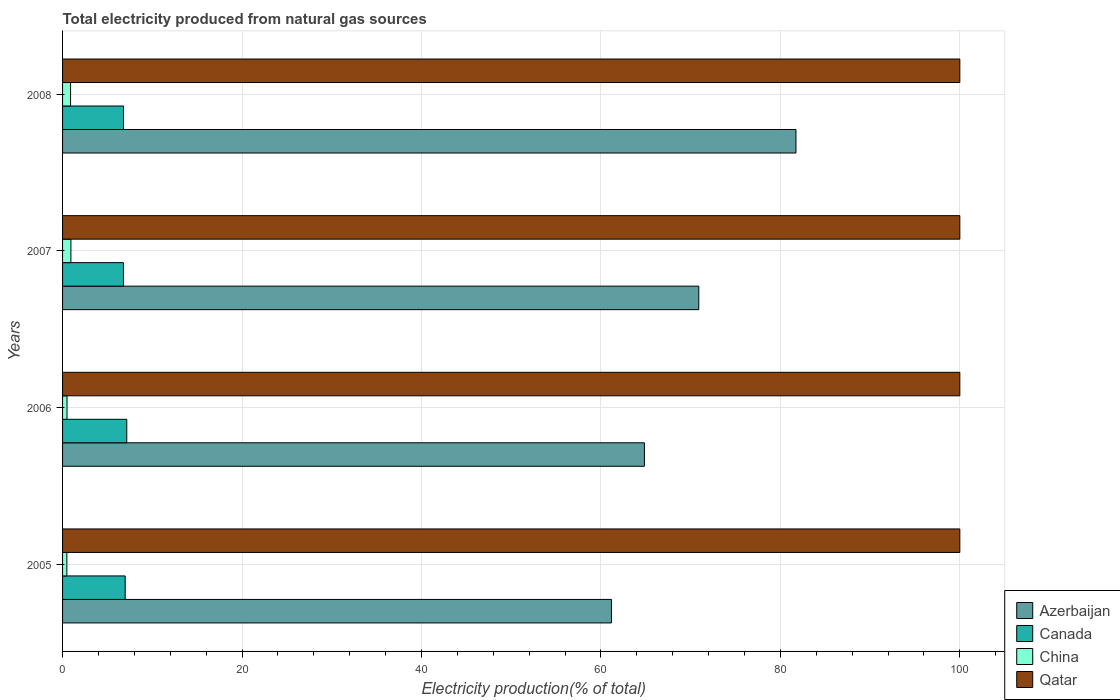Are the number of bars per tick equal to the number of legend labels?
Offer a terse response. Yes. How many bars are there on the 3rd tick from the bottom?
Provide a succinct answer. 4. In how many cases, is the number of bars for a given year not equal to the number of legend labels?
Provide a succinct answer. 0. What is the total electricity produced in Canada in 2008?
Your response must be concise. 6.79. Across all years, what is the maximum total electricity produced in Canada?
Your response must be concise. 7.15. In which year was the total electricity produced in Canada maximum?
Keep it short and to the point. 2006. In which year was the total electricity produced in Canada minimum?
Give a very brief answer. 2007. What is the total total electricity produced in China in the graph?
Ensure brevity in your answer.  2.79. What is the difference between the total electricity produced in China in 2006 and that in 2007?
Your answer should be compact. -0.43. What is the difference between the total electricity produced in China in 2005 and the total electricity produced in Azerbaijan in 2008?
Your response must be concise. -81.26. In the year 2006, what is the difference between the total electricity produced in Canada and total electricity produced in Qatar?
Offer a terse response. -92.85. In how many years, is the total electricity produced in Qatar greater than 80 %?
Keep it short and to the point. 4. What is the ratio of the total electricity produced in Qatar in 2005 to that in 2008?
Provide a succinct answer. 1. Is the total electricity produced in Canada in 2005 less than that in 2007?
Make the answer very short. No. What is the difference between the highest and the second highest total electricity produced in Azerbaijan?
Provide a succinct answer. 10.83. What is the difference between the highest and the lowest total electricity produced in Canada?
Your answer should be very brief. 0.37. In how many years, is the total electricity produced in Qatar greater than the average total electricity produced in Qatar taken over all years?
Your response must be concise. 0. Is the sum of the total electricity produced in Qatar in 2006 and 2007 greater than the maximum total electricity produced in Canada across all years?
Give a very brief answer. Yes. Is it the case that in every year, the sum of the total electricity produced in Azerbaijan and total electricity produced in Qatar is greater than the sum of total electricity produced in China and total electricity produced in Canada?
Your response must be concise. No. What does the 1st bar from the top in 2006 represents?
Make the answer very short. Qatar. What does the 1st bar from the bottom in 2007 represents?
Your answer should be compact. Azerbaijan. How many years are there in the graph?
Ensure brevity in your answer.  4. Does the graph contain grids?
Keep it short and to the point. Yes. How many legend labels are there?
Provide a succinct answer. 4. What is the title of the graph?
Provide a short and direct response. Total electricity produced from natural gas sources. Does "Belarus" appear as one of the legend labels in the graph?
Provide a short and direct response. No. What is the label or title of the X-axis?
Your answer should be very brief. Electricity production(% of total). What is the label or title of the Y-axis?
Ensure brevity in your answer.  Years. What is the Electricity production(% of total) in Azerbaijan in 2005?
Your response must be concise. 61.17. What is the Electricity production(% of total) of Canada in 2005?
Your answer should be compact. 6.98. What is the Electricity production(% of total) in China in 2005?
Your answer should be very brief. 0.48. What is the Electricity production(% of total) in Qatar in 2005?
Provide a short and direct response. 100. What is the Electricity production(% of total) of Azerbaijan in 2006?
Your answer should be very brief. 64.85. What is the Electricity production(% of total) of Canada in 2006?
Offer a very short reply. 7.15. What is the Electricity production(% of total) of China in 2006?
Your answer should be very brief. 0.5. What is the Electricity production(% of total) in Qatar in 2006?
Keep it short and to the point. 100. What is the Electricity production(% of total) in Azerbaijan in 2007?
Offer a terse response. 70.91. What is the Electricity production(% of total) of Canada in 2007?
Give a very brief answer. 6.78. What is the Electricity production(% of total) in China in 2007?
Give a very brief answer. 0.93. What is the Electricity production(% of total) in Qatar in 2007?
Keep it short and to the point. 100. What is the Electricity production(% of total) of Azerbaijan in 2008?
Offer a very short reply. 81.74. What is the Electricity production(% of total) in Canada in 2008?
Provide a succinct answer. 6.79. What is the Electricity production(% of total) in China in 2008?
Make the answer very short. 0.89. What is the Electricity production(% of total) of Qatar in 2008?
Your response must be concise. 100. Across all years, what is the maximum Electricity production(% of total) in Azerbaijan?
Give a very brief answer. 81.74. Across all years, what is the maximum Electricity production(% of total) in Canada?
Your response must be concise. 7.15. Across all years, what is the maximum Electricity production(% of total) of China?
Offer a terse response. 0.93. Across all years, what is the minimum Electricity production(% of total) of Azerbaijan?
Offer a very short reply. 61.17. Across all years, what is the minimum Electricity production(% of total) in Canada?
Make the answer very short. 6.78. Across all years, what is the minimum Electricity production(% of total) in China?
Offer a very short reply. 0.48. Across all years, what is the minimum Electricity production(% of total) of Qatar?
Ensure brevity in your answer.  100. What is the total Electricity production(% of total) of Azerbaijan in the graph?
Offer a terse response. 278.66. What is the total Electricity production(% of total) in Canada in the graph?
Your answer should be compact. 27.71. What is the total Electricity production(% of total) in China in the graph?
Your response must be concise. 2.79. What is the total Electricity production(% of total) of Qatar in the graph?
Provide a short and direct response. 400. What is the difference between the Electricity production(% of total) of Azerbaijan in 2005 and that in 2006?
Offer a very short reply. -3.67. What is the difference between the Electricity production(% of total) of Canada in 2005 and that in 2006?
Provide a succinct answer. -0.18. What is the difference between the Electricity production(% of total) of China in 2005 and that in 2006?
Make the answer very short. -0.02. What is the difference between the Electricity production(% of total) in Azerbaijan in 2005 and that in 2007?
Provide a short and direct response. -9.74. What is the difference between the Electricity production(% of total) of Canada in 2005 and that in 2007?
Provide a succinct answer. 0.2. What is the difference between the Electricity production(% of total) of China in 2005 and that in 2007?
Keep it short and to the point. -0.45. What is the difference between the Electricity production(% of total) of Qatar in 2005 and that in 2007?
Your response must be concise. 0. What is the difference between the Electricity production(% of total) of Azerbaijan in 2005 and that in 2008?
Your answer should be compact. -20.56. What is the difference between the Electricity production(% of total) of Canada in 2005 and that in 2008?
Provide a succinct answer. 0.19. What is the difference between the Electricity production(% of total) of China in 2005 and that in 2008?
Make the answer very short. -0.41. What is the difference between the Electricity production(% of total) in Azerbaijan in 2006 and that in 2007?
Ensure brevity in your answer.  -6.06. What is the difference between the Electricity production(% of total) in Canada in 2006 and that in 2007?
Give a very brief answer. 0.37. What is the difference between the Electricity production(% of total) in China in 2006 and that in 2007?
Offer a very short reply. -0.43. What is the difference between the Electricity production(% of total) of Qatar in 2006 and that in 2007?
Your answer should be very brief. 0. What is the difference between the Electricity production(% of total) in Azerbaijan in 2006 and that in 2008?
Keep it short and to the point. -16.89. What is the difference between the Electricity production(% of total) in Canada in 2006 and that in 2008?
Offer a very short reply. 0.36. What is the difference between the Electricity production(% of total) of China in 2006 and that in 2008?
Offer a very short reply. -0.4. What is the difference between the Electricity production(% of total) of Qatar in 2006 and that in 2008?
Your response must be concise. 0. What is the difference between the Electricity production(% of total) of Azerbaijan in 2007 and that in 2008?
Offer a terse response. -10.83. What is the difference between the Electricity production(% of total) in Canada in 2007 and that in 2008?
Give a very brief answer. -0.01. What is the difference between the Electricity production(% of total) in China in 2007 and that in 2008?
Make the answer very short. 0.04. What is the difference between the Electricity production(% of total) of Azerbaijan in 2005 and the Electricity production(% of total) of Canada in 2006?
Provide a succinct answer. 54.02. What is the difference between the Electricity production(% of total) of Azerbaijan in 2005 and the Electricity production(% of total) of China in 2006?
Ensure brevity in your answer.  60.68. What is the difference between the Electricity production(% of total) of Azerbaijan in 2005 and the Electricity production(% of total) of Qatar in 2006?
Keep it short and to the point. -38.83. What is the difference between the Electricity production(% of total) in Canada in 2005 and the Electricity production(% of total) in China in 2006?
Offer a terse response. 6.48. What is the difference between the Electricity production(% of total) of Canada in 2005 and the Electricity production(% of total) of Qatar in 2006?
Offer a very short reply. -93.02. What is the difference between the Electricity production(% of total) of China in 2005 and the Electricity production(% of total) of Qatar in 2006?
Make the answer very short. -99.52. What is the difference between the Electricity production(% of total) in Azerbaijan in 2005 and the Electricity production(% of total) in Canada in 2007?
Make the answer very short. 54.39. What is the difference between the Electricity production(% of total) of Azerbaijan in 2005 and the Electricity production(% of total) of China in 2007?
Your answer should be compact. 60.24. What is the difference between the Electricity production(% of total) of Azerbaijan in 2005 and the Electricity production(% of total) of Qatar in 2007?
Your answer should be very brief. -38.83. What is the difference between the Electricity production(% of total) in Canada in 2005 and the Electricity production(% of total) in China in 2007?
Offer a terse response. 6.05. What is the difference between the Electricity production(% of total) of Canada in 2005 and the Electricity production(% of total) of Qatar in 2007?
Ensure brevity in your answer.  -93.02. What is the difference between the Electricity production(% of total) in China in 2005 and the Electricity production(% of total) in Qatar in 2007?
Your response must be concise. -99.52. What is the difference between the Electricity production(% of total) of Azerbaijan in 2005 and the Electricity production(% of total) of Canada in 2008?
Your answer should be very brief. 54.38. What is the difference between the Electricity production(% of total) of Azerbaijan in 2005 and the Electricity production(% of total) of China in 2008?
Your answer should be very brief. 60.28. What is the difference between the Electricity production(% of total) in Azerbaijan in 2005 and the Electricity production(% of total) in Qatar in 2008?
Ensure brevity in your answer.  -38.83. What is the difference between the Electricity production(% of total) of Canada in 2005 and the Electricity production(% of total) of China in 2008?
Offer a very short reply. 6.09. What is the difference between the Electricity production(% of total) in Canada in 2005 and the Electricity production(% of total) in Qatar in 2008?
Ensure brevity in your answer.  -93.02. What is the difference between the Electricity production(% of total) in China in 2005 and the Electricity production(% of total) in Qatar in 2008?
Make the answer very short. -99.52. What is the difference between the Electricity production(% of total) in Azerbaijan in 2006 and the Electricity production(% of total) in Canada in 2007?
Ensure brevity in your answer.  58.06. What is the difference between the Electricity production(% of total) of Azerbaijan in 2006 and the Electricity production(% of total) of China in 2007?
Provide a succinct answer. 63.92. What is the difference between the Electricity production(% of total) in Azerbaijan in 2006 and the Electricity production(% of total) in Qatar in 2007?
Offer a very short reply. -35.15. What is the difference between the Electricity production(% of total) of Canada in 2006 and the Electricity production(% of total) of China in 2007?
Keep it short and to the point. 6.23. What is the difference between the Electricity production(% of total) of Canada in 2006 and the Electricity production(% of total) of Qatar in 2007?
Give a very brief answer. -92.85. What is the difference between the Electricity production(% of total) of China in 2006 and the Electricity production(% of total) of Qatar in 2007?
Your answer should be compact. -99.5. What is the difference between the Electricity production(% of total) of Azerbaijan in 2006 and the Electricity production(% of total) of Canada in 2008?
Offer a terse response. 58.05. What is the difference between the Electricity production(% of total) in Azerbaijan in 2006 and the Electricity production(% of total) in China in 2008?
Make the answer very short. 63.95. What is the difference between the Electricity production(% of total) in Azerbaijan in 2006 and the Electricity production(% of total) in Qatar in 2008?
Offer a terse response. -35.15. What is the difference between the Electricity production(% of total) of Canada in 2006 and the Electricity production(% of total) of China in 2008?
Your response must be concise. 6.26. What is the difference between the Electricity production(% of total) in Canada in 2006 and the Electricity production(% of total) in Qatar in 2008?
Make the answer very short. -92.85. What is the difference between the Electricity production(% of total) of China in 2006 and the Electricity production(% of total) of Qatar in 2008?
Offer a terse response. -99.5. What is the difference between the Electricity production(% of total) in Azerbaijan in 2007 and the Electricity production(% of total) in Canada in 2008?
Your answer should be compact. 64.11. What is the difference between the Electricity production(% of total) of Azerbaijan in 2007 and the Electricity production(% of total) of China in 2008?
Offer a terse response. 70.02. What is the difference between the Electricity production(% of total) of Azerbaijan in 2007 and the Electricity production(% of total) of Qatar in 2008?
Keep it short and to the point. -29.09. What is the difference between the Electricity production(% of total) of Canada in 2007 and the Electricity production(% of total) of China in 2008?
Provide a short and direct response. 5.89. What is the difference between the Electricity production(% of total) of Canada in 2007 and the Electricity production(% of total) of Qatar in 2008?
Offer a terse response. -93.22. What is the difference between the Electricity production(% of total) of China in 2007 and the Electricity production(% of total) of Qatar in 2008?
Keep it short and to the point. -99.07. What is the average Electricity production(% of total) of Azerbaijan per year?
Your response must be concise. 69.66. What is the average Electricity production(% of total) of Canada per year?
Offer a very short reply. 6.93. What is the average Electricity production(% of total) of China per year?
Offer a terse response. 0.7. In the year 2005, what is the difference between the Electricity production(% of total) of Azerbaijan and Electricity production(% of total) of Canada?
Offer a very short reply. 54.19. In the year 2005, what is the difference between the Electricity production(% of total) of Azerbaijan and Electricity production(% of total) of China?
Provide a succinct answer. 60.69. In the year 2005, what is the difference between the Electricity production(% of total) in Azerbaijan and Electricity production(% of total) in Qatar?
Give a very brief answer. -38.83. In the year 2005, what is the difference between the Electricity production(% of total) of Canada and Electricity production(% of total) of China?
Your response must be concise. 6.5. In the year 2005, what is the difference between the Electricity production(% of total) of Canada and Electricity production(% of total) of Qatar?
Make the answer very short. -93.02. In the year 2005, what is the difference between the Electricity production(% of total) in China and Electricity production(% of total) in Qatar?
Your answer should be compact. -99.52. In the year 2006, what is the difference between the Electricity production(% of total) in Azerbaijan and Electricity production(% of total) in Canada?
Provide a succinct answer. 57.69. In the year 2006, what is the difference between the Electricity production(% of total) of Azerbaijan and Electricity production(% of total) of China?
Keep it short and to the point. 64.35. In the year 2006, what is the difference between the Electricity production(% of total) of Azerbaijan and Electricity production(% of total) of Qatar?
Ensure brevity in your answer.  -35.15. In the year 2006, what is the difference between the Electricity production(% of total) of Canada and Electricity production(% of total) of China?
Your answer should be compact. 6.66. In the year 2006, what is the difference between the Electricity production(% of total) in Canada and Electricity production(% of total) in Qatar?
Offer a very short reply. -92.85. In the year 2006, what is the difference between the Electricity production(% of total) in China and Electricity production(% of total) in Qatar?
Provide a short and direct response. -99.5. In the year 2007, what is the difference between the Electricity production(% of total) in Azerbaijan and Electricity production(% of total) in Canada?
Offer a terse response. 64.12. In the year 2007, what is the difference between the Electricity production(% of total) in Azerbaijan and Electricity production(% of total) in China?
Your answer should be very brief. 69.98. In the year 2007, what is the difference between the Electricity production(% of total) of Azerbaijan and Electricity production(% of total) of Qatar?
Provide a short and direct response. -29.09. In the year 2007, what is the difference between the Electricity production(% of total) in Canada and Electricity production(% of total) in China?
Keep it short and to the point. 5.85. In the year 2007, what is the difference between the Electricity production(% of total) in Canada and Electricity production(% of total) in Qatar?
Ensure brevity in your answer.  -93.22. In the year 2007, what is the difference between the Electricity production(% of total) of China and Electricity production(% of total) of Qatar?
Offer a very short reply. -99.07. In the year 2008, what is the difference between the Electricity production(% of total) of Azerbaijan and Electricity production(% of total) of Canada?
Your answer should be compact. 74.94. In the year 2008, what is the difference between the Electricity production(% of total) in Azerbaijan and Electricity production(% of total) in China?
Your answer should be very brief. 80.84. In the year 2008, what is the difference between the Electricity production(% of total) of Azerbaijan and Electricity production(% of total) of Qatar?
Offer a terse response. -18.26. In the year 2008, what is the difference between the Electricity production(% of total) in Canada and Electricity production(% of total) in China?
Give a very brief answer. 5.9. In the year 2008, what is the difference between the Electricity production(% of total) of Canada and Electricity production(% of total) of Qatar?
Give a very brief answer. -93.21. In the year 2008, what is the difference between the Electricity production(% of total) in China and Electricity production(% of total) in Qatar?
Your answer should be very brief. -99.11. What is the ratio of the Electricity production(% of total) of Azerbaijan in 2005 to that in 2006?
Give a very brief answer. 0.94. What is the ratio of the Electricity production(% of total) in Canada in 2005 to that in 2006?
Your answer should be compact. 0.98. What is the ratio of the Electricity production(% of total) of China in 2005 to that in 2006?
Offer a very short reply. 0.96. What is the ratio of the Electricity production(% of total) in Qatar in 2005 to that in 2006?
Give a very brief answer. 1. What is the ratio of the Electricity production(% of total) in Azerbaijan in 2005 to that in 2007?
Offer a very short reply. 0.86. What is the ratio of the Electricity production(% of total) of Canada in 2005 to that in 2007?
Make the answer very short. 1.03. What is the ratio of the Electricity production(% of total) in China in 2005 to that in 2007?
Your response must be concise. 0.51. What is the ratio of the Electricity production(% of total) in Azerbaijan in 2005 to that in 2008?
Your response must be concise. 0.75. What is the ratio of the Electricity production(% of total) of Canada in 2005 to that in 2008?
Give a very brief answer. 1.03. What is the ratio of the Electricity production(% of total) of China in 2005 to that in 2008?
Keep it short and to the point. 0.54. What is the ratio of the Electricity production(% of total) of Qatar in 2005 to that in 2008?
Provide a succinct answer. 1. What is the ratio of the Electricity production(% of total) in Azerbaijan in 2006 to that in 2007?
Offer a very short reply. 0.91. What is the ratio of the Electricity production(% of total) of Canada in 2006 to that in 2007?
Give a very brief answer. 1.05. What is the ratio of the Electricity production(% of total) of China in 2006 to that in 2007?
Give a very brief answer. 0.53. What is the ratio of the Electricity production(% of total) in Qatar in 2006 to that in 2007?
Offer a terse response. 1. What is the ratio of the Electricity production(% of total) in Azerbaijan in 2006 to that in 2008?
Offer a terse response. 0.79. What is the ratio of the Electricity production(% of total) in Canada in 2006 to that in 2008?
Your answer should be compact. 1.05. What is the ratio of the Electricity production(% of total) of China in 2006 to that in 2008?
Provide a short and direct response. 0.56. What is the ratio of the Electricity production(% of total) in Qatar in 2006 to that in 2008?
Ensure brevity in your answer.  1. What is the ratio of the Electricity production(% of total) of Azerbaijan in 2007 to that in 2008?
Offer a terse response. 0.87. What is the ratio of the Electricity production(% of total) in Canada in 2007 to that in 2008?
Provide a succinct answer. 1. What is the ratio of the Electricity production(% of total) of China in 2007 to that in 2008?
Provide a short and direct response. 1.04. What is the ratio of the Electricity production(% of total) of Qatar in 2007 to that in 2008?
Provide a succinct answer. 1. What is the difference between the highest and the second highest Electricity production(% of total) in Azerbaijan?
Ensure brevity in your answer.  10.83. What is the difference between the highest and the second highest Electricity production(% of total) in Canada?
Keep it short and to the point. 0.18. What is the difference between the highest and the second highest Electricity production(% of total) in China?
Give a very brief answer. 0.04. What is the difference between the highest and the lowest Electricity production(% of total) of Azerbaijan?
Keep it short and to the point. 20.56. What is the difference between the highest and the lowest Electricity production(% of total) of Canada?
Offer a terse response. 0.37. What is the difference between the highest and the lowest Electricity production(% of total) in China?
Your response must be concise. 0.45. 